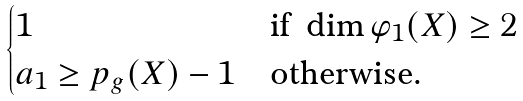Convert formula to latex. <formula><loc_0><loc_0><loc_500><loc_500>\begin{cases} 1 & \text {if} \ \dim \varphi _ { 1 } ( X ) \geq 2 \\ a _ { 1 } \geq p _ { g } ( X ) - 1 & \text {otherwise.} \end{cases}</formula> 